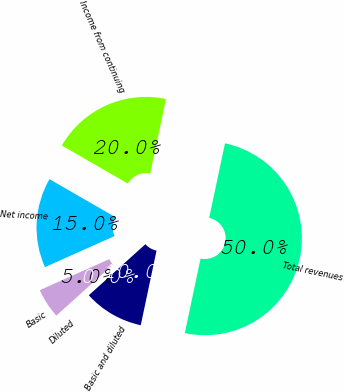Convert chart to OTSL. <chart><loc_0><loc_0><loc_500><loc_500><pie_chart><fcel>Total revenues<fcel>Income from continuing<fcel>Net income<fcel>Basic<fcel>Diluted<fcel>Basic and diluted<nl><fcel>49.99%<fcel>20.0%<fcel>15.0%<fcel>5.0%<fcel>0.0%<fcel>10.0%<nl></chart> 